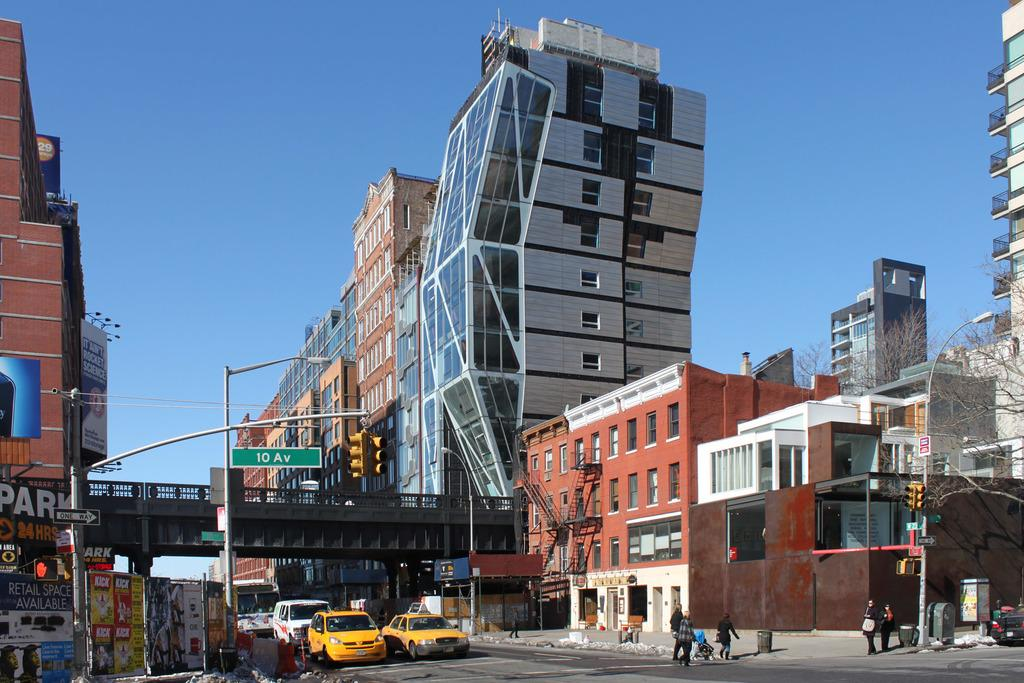<image>
Render a clear and concise summary of the photo. A city scene showing an intersection of 10th Ave. 